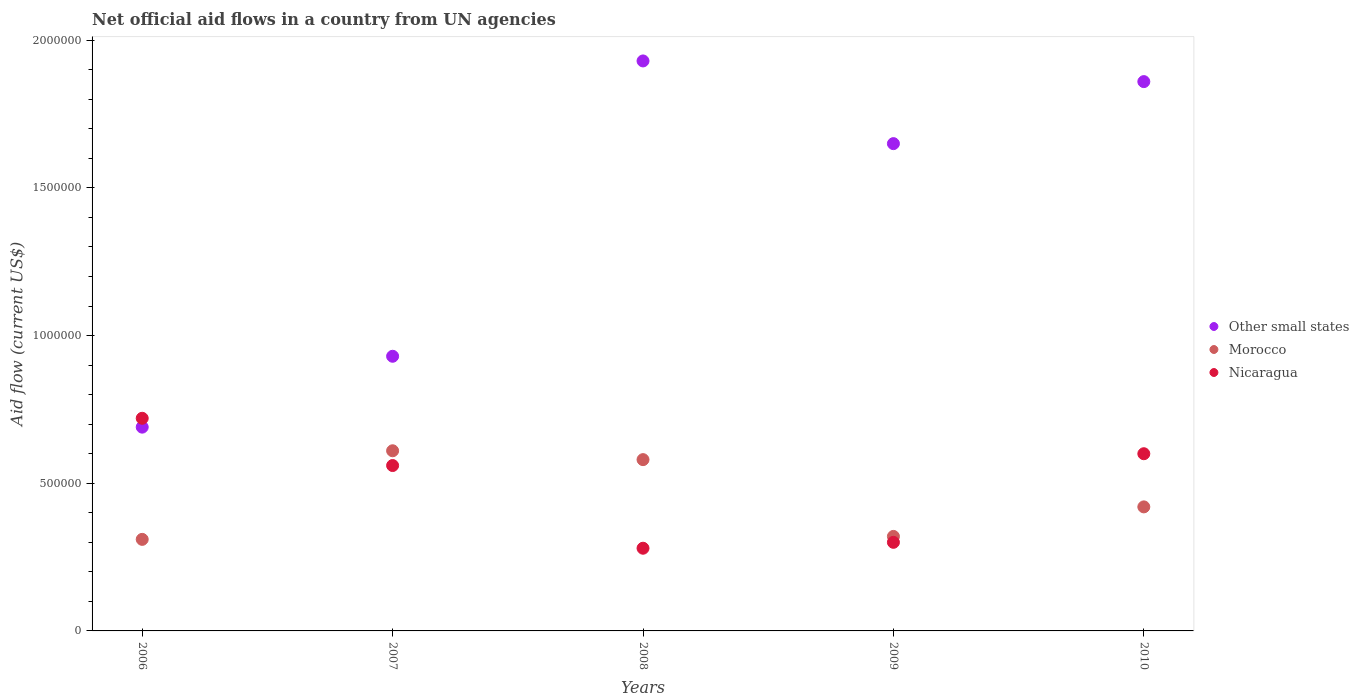Is the number of dotlines equal to the number of legend labels?
Provide a short and direct response. Yes. What is the net official aid flow in Other small states in 2008?
Offer a very short reply. 1.93e+06. Across all years, what is the maximum net official aid flow in Nicaragua?
Provide a succinct answer. 7.20e+05. Across all years, what is the minimum net official aid flow in Morocco?
Your response must be concise. 3.10e+05. In which year was the net official aid flow in Morocco maximum?
Make the answer very short. 2007. In which year was the net official aid flow in Morocco minimum?
Your answer should be compact. 2006. What is the total net official aid flow in Morocco in the graph?
Your response must be concise. 2.24e+06. What is the difference between the net official aid flow in Nicaragua in 2007 and that in 2010?
Make the answer very short. -4.00e+04. What is the difference between the net official aid flow in Nicaragua in 2006 and the net official aid flow in Other small states in 2009?
Provide a short and direct response. -9.30e+05. What is the average net official aid flow in Other small states per year?
Offer a very short reply. 1.41e+06. In the year 2009, what is the difference between the net official aid flow in Other small states and net official aid flow in Morocco?
Give a very brief answer. 1.33e+06. In how many years, is the net official aid flow in Nicaragua greater than 1400000 US$?
Provide a short and direct response. 0. What is the ratio of the net official aid flow in Morocco in 2009 to that in 2010?
Offer a terse response. 0.76. Is the net official aid flow in Morocco in 2006 less than that in 2010?
Ensure brevity in your answer.  Yes. What is the difference between the highest and the lowest net official aid flow in Other small states?
Provide a short and direct response. 1.24e+06. Is it the case that in every year, the sum of the net official aid flow in Nicaragua and net official aid flow in Morocco  is greater than the net official aid flow in Other small states?
Offer a very short reply. No. Is the net official aid flow in Nicaragua strictly less than the net official aid flow in Other small states over the years?
Provide a succinct answer. No. How many dotlines are there?
Your answer should be compact. 3. What is the difference between two consecutive major ticks on the Y-axis?
Your response must be concise. 5.00e+05. Are the values on the major ticks of Y-axis written in scientific E-notation?
Ensure brevity in your answer.  No. Does the graph contain grids?
Offer a terse response. No. Where does the legend appear in the graph?
Give a very brief answer. Center right. How many legend labels are there?
Make the answer very short. 3. What is the title of the graph?
Offer a very short reply. Net official aid flows in a country from UN agencies. Does "Yemen, Rep." appear as one of the legend labels in the graph?
Offer a very short reply. No. What is the Aid flow (current US$) of Other small states in 2006?
Provide a short and direct response. 6.90e+05. What is the Aid flow (current US$) in Morocco in 2006?
Provide a short and direct response. 3.10e+05. What is the Aid flow (current US$) of Nicaragua in 2006?
Provide a short and direct response. 7.20e+05. What is the Aid flow (current US$) in Other small states in 2007?
Provide a succinct answer. 9.30e+05. What is the Aid flow (current US$) in Nicaragua in 2007?
Keep it short and to the point. 5.60e+05. What is the Aid flow (current US$) of Other small states in 2008?
Offer a very short reply. 1.93e+06. What is the Aid flow (current US$) of Morocco in 2008?
Give a very brief answer. 5.80e+05. What is the Aid flow (current US$) of Nicaragua in 2008?
Your answer should be compact. 2.80e+05. What is the Aid flow (current US$) of Other small states in 2009?
Keep it short and to the point. 1.65e+06. What is the Aid flow (current US$) of Morocco in 2009?
Provide a succinct answer. 3.20e+05. What is the Aid flow (current US$) of Other small states in 2010?
Give a very brief answer. 1.86e+06. What is the Aid flow (current US$) of Morocco in 2010?
Your response must be concise. 4.20e+05. What is the Aid flow (current US$) in Nicaragua in 2010?
Offer a very short reply. 6.00e+05. Across all years, what is the maximum Aid flow (current US$) in Other small states?
Give a very brief answer. 1.93e+06. Across all years, what is the maximum Aid flow (current US$) in Nicaragua?
Offer a very short reply. 7.20e+05. Across all years, what is the minimum Aid flow (current US$) of Other small states?
Make the answer very short. 6.90e+05. What is the total Aid flow (current US$) of Other small states in the graph?
Ensure brevity in your answer.  7.06e+06. What is the total Aid flow (current US$) in Morocco in the graph?
Your answer should be very brief. 2.24e+06. What is the total Aid flow (current US$) in Nicaragua in the graph?
Ensure brevity in your answer.  2.46e+06. What is the difference between the Aid flow (current US$) in Other small states in 2006 and that in 2007?
Offer a very short reply. -2.40e+05. What is the difference between the Aid flow (current US$) in Morocco in 2006 and that in 2007?
Your response must be concise. -3.00e+05. What is the difference between the Aid flow (current US$) in Nicaragua in 2006 and that in 2007?
Ensure brevity in your answer.  1.60e+05. What is the difference between the Aid flow (current US$) of Other small states in 2006 and that in 2008?
Make the answer very short. -1.24e+06. What is the difference between the Aid flow (current US$) of Nicaragua in 2006 and that in 2008?
Your answer should be very brief. 4.40e+05. What is the difference between the Aid flow (current US$) of Other small states in 2006 and that in 2009?
Your answer should be compact. -9.60e+05. What is the difference between the Aid flow (current US$) of Morocco in 2006 and that in 2009?
Offer a very short reply. -10000. What is the difference between the Aid flow (current US$) in Nicaragua in 2006 and that in 2009?
Ensure brevity in your answer.  4.20e+05. What is the difference between the Aid flow (current US$) in Other small states in 2006 and that in 2010?
Offer a very short reply. -1.17e+06. What is the difference between the Aid flow (current US$) of Morocco in 2006 and that in 2010?
Offer a very short reply. -1.10e+05. What is the difference between the Aid flow (current US$) in Nicaragua in 2006 and that in 2010?
Provide a succinct answer. 1.20e+05. What is the difference between the Aid flow (current US$) of Other small states in 2007 and that in 2008?
Provide a succinct answer. -1.00e+06. What is the difference between the Aid flow (current US$) of Morocco in 2007 and that in 2008?
Offer a very short reply. 3.00e+04. What is the difference between the Aid flow (current US$) in Nicaragua in 2007 and that in 2008?
Your answer should be very brief. 2.80e+05. What is the difference between the Aid flow (current US$) in Other small states in 2007 and that in 2009?
Keep it short and to the point. -7.20e+05. What is the difference between the Aid flow (current US$) of Other small states in 2007 and that in 2010?
Offer a terse response. -9.30e+05. What is the difference between the Aid flow (current US$) of Other small states in 2008 and that in 2010?
Make the answer very short. 7.00e+04. What is the difference between the Aid flow (current US$) in Nicaragua in 2008 and that in 2010?
Give a very brief answer. -3.20e+05. What is the difference between the Aid flow (current US$) of Other small states in 2009 and that in 2010?
Offer a terse response. -2.10e+05. What is the difference between the Aid flow (current US$) of Nicaragua in 2009 and that in 2010?
Provide a short and direct response. -3.00e+05. What is the difference between the Aid flow (current US$) in Other small states in 2006 and the Aid flow (current US$) in Morocco in 2007?
Provide a succinct answer. 8.00e+04. What is the difference between the Aid flow (current US$) in Morocco in 2006 and the Aid flow (current US$) in Nicaragua in 2007?
Provide a short and direct response. -2.50e+05. What is the difference between the Aid flow (current US$) in Other small states in 2006 and the Aid flow (current US$) in Morocco in 2008?
Your answer should be compact. 1.10e+05. What is the difference between the Aid flow (current US$) in Other small states in 2006 and the Aid flow (current US$) in Nicaragua in 2008?
Provide a short and direct response. 4.10e+05. What is the difference between the Aid flow (current US$) in Morocco in 2006 and the Aid flow (current US$) in Nicaragua in 2008?
Provide a succinct answer. 3.00e+04. What is the difference between the Aid flow (current US$) of Morocco in 2006 and the Aid flow (current US$) of Nicaragua in 2009?
Provide a short and direct response. 10000. What is the difference between the Aid flow (current US$) in Other small states in 2007 and the Aid flow (current US$) in Morocco in 2008?
Make the answer very short. 3.50e+05. What is the difference between the Aid flow (current US$) in Other small states in 2007 and the Aid flow (current US$) in Nicaragua in 2008?
Your response must be concise. 6.50e+05. What is the difference between the Aid flow (current US$) in Other small states in 2007 and the Aid flow (current US$) in Morocco in 2009?
Your answer should be very brief. 6.10e+05. What is the difference between the Aid flow (current US$) of Other small states in 2007 and the Aid flow (current US$) of Nicaragua in 2009?
Ensure brevity in your answer.  6.30e+05. What is the difference between the Aid flow (current US$) of Morocco in 2007 and the Aid flow (current US$) of Nicaragua in 2009?
Ensure brevity in your answer.  3.10e+05. What is the difference between the Aid flow (current US$) of Other small states in 2007 and the Aid flow (current US$) of Morocco in 2010?
Provide a short and direct response. 5.10e+05. What is the difference between the Aid flow (current US$) in Other small states in 2008 and the Aid flow (current US$) in Morocco in 2009?
Keep it short and to the point. 1.61e+06. What is the difference between the Aid flow (current US$) of Other small states in 2008 and the Aid flow (current US$) of Nicaragua in 2009?
Keep it short and to the point. 1.63e+06. What is the difference between the Aid flow (current US$) of Morocco in 2008 and the Aid flow (current US$) of Nicaragua in 2009?
Offer a terse response. 2.80e+05. What is the difference between the Aid flow (current US$) in Other small states in 2008 and the Aid flow (current US$) in Morocco in 2010?
Offer a very short reply. 1.51e+06. What is the difference between the Aid flow (current US$) of Other small states in 2008 and the Aid flow (current US$) of Nicaragua in 2010?
Offer a terse response. 1.33e+06. What is the difference between the Aid flow (current US$) in Morocco in 2008 and the Aid flow (current US$) in Nicaragua in 2010?
Offer a very short reply. -2.00e+04. What is the difference between the Aid flow (current US$) of Other small states in 2009 and the Aid flow (current US$) of Morocco in 2010?
Offer a terse response. 1.23e+06. What is the difference between the Aid flow (current US$) in Other small states in 2009 and the Aid flow (current US$) in Nicaragua in 2010?
Give a very brief answer. 1.05e+06. What is the difference between the Aid flow (current US$) of Morocco in 2009 and the Aid flow (current US$) of Nicaragua in 2010?
Your answer should be very brief. -2.80e+05. What is the average Aid flow (current US$) in Other small states per year?
Your response must be concise. 1.41e+06. What is the average Aid flow (current US$) in Morocco per year?
Keep it short and to the point. 4.48e+05. What is the average Aid flow (current US$) in Nicaragua per year?
Make the answer very short. 4.92e+05. In the year 2006, what is the difference between the Aid flow (current US$) of Other small states and Aid flow (current US$) of Morocco?
Provide a succinct answer. 3.80e+05. In the year 2006, what is the difference between the Aid flow (current US$) in Morocco and Aid flow (current US$) in Nicaragua?
Give a very brief answer. -4.10e+05. In the year 2007, what is the difference between the Aid flow (current US$) in Morocco and Aid flow (current US$) in Nicaragua?
Keep it short and to the point. 5.00e+04. In the year 2008, what is the difference between the Aid flow (current US$) in Other small states and Aid flow (current US$) in Morocco?
Give a very brief answer. 1.35e+06. In the year 2008, what is the difference between the Aid flow (current US$) in Other small states and Aid flow (current US$) in Nicaragua?
Offer a terse response. 1.65e+06. In the year 2009, what is the difference between the Aid flow (current US$) of Other small states and Aid flow (current US$) of Morocco?
Make the answer very short. 1.33e+06. In the year 2009, what is the difference between the Aid flow (current US$) in Other small states and Aid flow (current US$) in Nicaragua?
Ensure brevity in your answer.  1.35e+06. In the year 2009, what is the difference between the Aid flow (current US$) of Morocco and Aid flow (current US$) of Nicaragua?
Provide a succinct answer. 2.00e+04. In the year 2010, what is the difference between the Aid flow (current US$) of Other small states and Aid flow (current US$) of Morocco?
Give a very brief answer. 1.44e+06. In the year 2010, what is the difference between the Aid flow (current US$) in Other small states and Aid flow (current US$) in Nicaragua?
Offer a terse response. 1.26e+06. In the year 2010, what is the difference between the Aid flow (current US$) in Morocco and Aid flow (current US$) in Nicaragua?
Your answer should be compact. -1.80e+05. What is the ratio of the Aid flow (current US$) in Other small states in 2006 to that in 2007?
Give a very brief answer. 0.74. What is the ratio of the Aid flow (current US$) in Morocco in 2006 to that in 2007?
Your answer should be compact. 0.51. What is the ratio of the Aid flow (current US$) of Other small states in 2006 to that in 2008?
Provide a succinct answer. 0.36. What is the ratio of the Aid flow (current US$) of Morocco in 2006 to that in 2008?
Keep it short and to the point. 0.53. What is the ratio of the Aid flow (current US$) in Nicaragua in 2006 to that in 2008?
Ensure brevity in your answer.  2.57. What is the ratio of the Aid flow (current US$) in Other small states in 2006 to that in 2009?
Offer a very short reply. 0.42. What is the ratio of the Aid flow (current US$) in Morocco in 2006 to that in 2009?
Your answer should be very brief. 0.97. What is the ratio of the Aid flow (current US$) in Nicaragua in 2006 to that in 2009?
Keep it short and to the point. 2.4. What is the ratio of the Aid flow (current US$) in Other small states in 2006 to that in 2010?
Your answer should be very brief. 0.37. What is the ratio of the Aid flow (current US$) of Morocco in 2006 to that in 2010?
Offer a terse response. 0.74. What is the ratio of the Aid flow (current US$) in Other small states in 2007 to that in 2008?
Your answer should be compact. 0.48. What is the ratio of the Aid flow (current US$) in Morocco in 2007 to that in 2008?
Offer a terse response. 1.05. What is the ratio of the Aid flow (current US$) in Other small states in 2007 to that in 2009?
Make the answer very short. 0.56. What is the ratio of the Aid flow (current US$) of Morocco in 2007 to that in 2009?
Your answer should be compact. 1.91. What is the ratio of the Aid flow (current US$) in Nicaragua in 2007 to that in 2009?
Offer a terse response. 1.87. What is the ratio of the Aid flow (current US$) of Morocco in 2007 to that in 2010?
Your answer should be compact. 1.45. What is the ratio of the Aid flow (current US$) in Nicaragua in 2007 to that in 2010?
Give a very brief answer. 0.93. What is the ratio of the Aid flow (current US$) in Other small states in 2008 to that in 2009?
Offer a very short reply. 1.17. What is the ratio of the Aid flow (current US$) in Morocco in 2008 to that in 2009?
Your answer should be very brief. 1.81. What is the ratio of the Aid flow (current US$) of Nicaragua in 2008 to that in 2009?
Keep it short and to the point. 0.93. What is the ratio of the Aid flow (current US$) of Other small states in 2008 to that in 2010?
Your answer should be very brief. 1.04. What is the ratio of the Aid flow (current US$) in Morocco in 2008 to that in 2010?
Offer a terse response. 1.38. What is the ratio of the Aid flow (current US$) of Nicaragua in 2008 to that in 2010?
Provide a succinct answer. 0.47. What is the ratio of the Aid flow (current US$) of Other small states in 2009 to that in 2010?
Give a very brief answer. 0.89. What is the ratio of the Aid flow (current US$) of Morocco in 2009 to that in 2010?
Give a very brief answer. 0.76. What is the ratio of the Aid flow (current US$) in Nicaragua in 2009 to that in 2010?
Make the answer very short. 0.5. What is the difference between the highest and the second highest Aid flow (current US$) in Morocco?
Provide a short and direct response. 3.00e+04. What is the difference between the highest and the second highest Aid flow (current US$) of Nicaragua?
Make the answer very short. 1.20e+05. What is the difference between the highest and the lowest Aid flow (current US$) in Other small states?
Make the answer very short. 1.24e+06. What is the difference between the highest and the lowest Aid flow (current US$) of Morocco?
Offer a very short reply. 3.00e+05. 